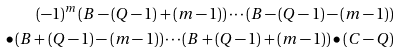<formula> <loc_0><loc_0><loc_500><loc_500>( - 1 ) ^ { m } \left ( B - ( Q - 1 ) + ( m - 1 ) \right ) \cdots \left ( B - ( Q - 1 ) - ( m - 1 ) \right ) \\ \bullet \left ( B + ( Q - 1 ) - ( m - 1 ) \right ) \cdots \left ( B + ( Q - 1 ) + ( m - 1 ) \right ) \bullet ( C - Q )</formula> 